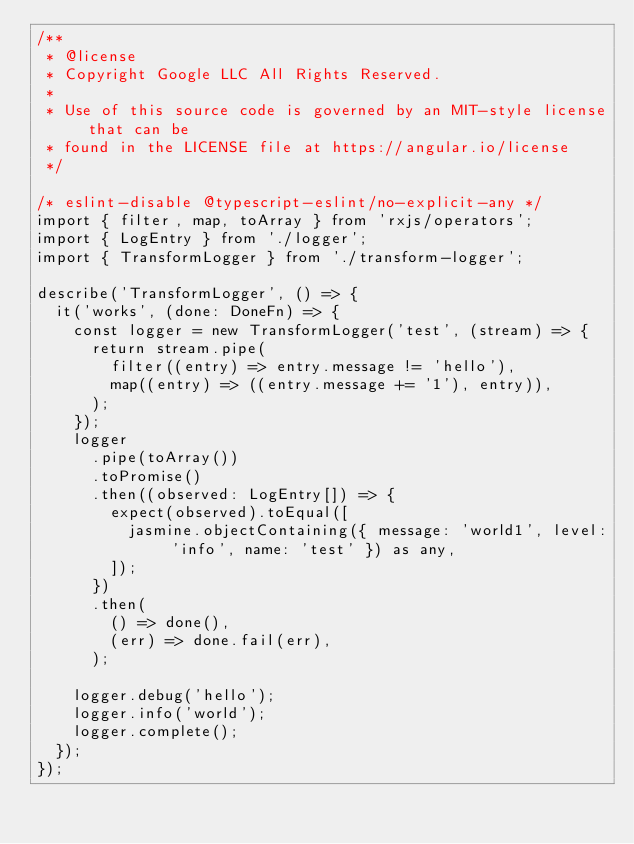<code> <loc_0><loc_0><loc_500><loc_500><_TypeScript_>/**
 * @license
 * Copyright Google LLC All Rights Reserved.
 *
 * Use of this source code is governed by an MIT-style license that can be
 * found in the LICENSE file at https://angular.io/license
 */

/* eslint-disable @typescript-eslint/no-explicit-any */
import { filter, map, toArray } from 'rxjs/operators';
import { LogEntry } from './logger';
import { TransformLogger } from './transform-logger';

describe('TransformLogger', () => {
  it('works', (done: DoneFn) => {
    const logger = new TransformLogger('test', (stream) => {
      return stream.pipe(
        filter((entry) => entry.message != 'hello'),
        map((entry) => ((entry.message += '1'), entry)),
      );
    });
    logger
      .pipe(toArray())
      .toPromise()
      .then((observed: LogEntry[]) => {
        expect(observed).toEqual([
          jasmine.objectContaining({ message: 'world1', level: 'info', name: 'test' }) as any,
        ]);
      })
      .then(
        () => done(),
        (err) => done.fail(err),
      );

    logger.debug('hello');
    logger.info('world');
    logger.complete();
  });
});
</code> 